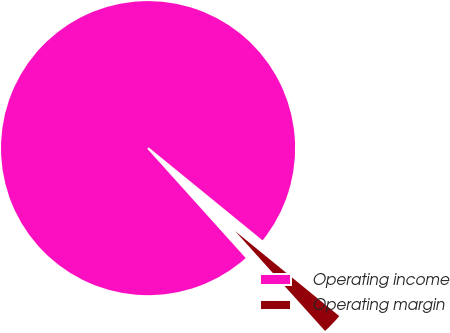Convert chart to OTSL. <chart><loc_0><loc_0><loc_500><loc_500><pie_chart><fcel>Operating income<fcel>Operating margin<nl><fcel>97.56%<fcel>2.44%<nl></chart> 